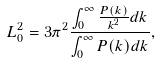Convert formula to latex. <formula><loc_0><loc_0><loc_500><loc_500>L _ { 0 } ^ { 2 } = 3 \pi ^ { 2 } \frac { \int _ { 0 } ^ { \infty } \frac { P ( k ) } { k ^ { 2 } } d k } { \int _ { 0 } ^ { \infty } P ( k ) d k } ,</formula> 